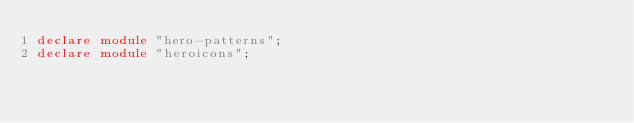<code> <loc_0><loc_0><loc_500><loc_500><_TypeScript_>declare module "hero-patterns";
declare module "heroicons";
</code> 